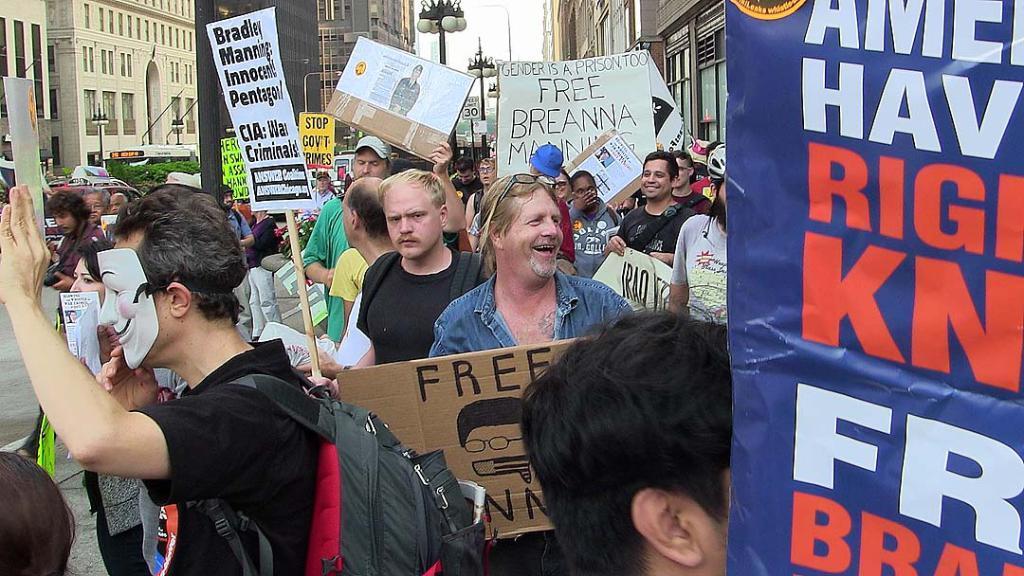Can you describe this image briefly? In this image there are a group of people who are holding some placards, and in the foreground there is one person who is wearing a mask and some of them are holding some boards. In the background there are buildings, trees, pole, lights and on the right side there is one board. On the board there is text. 